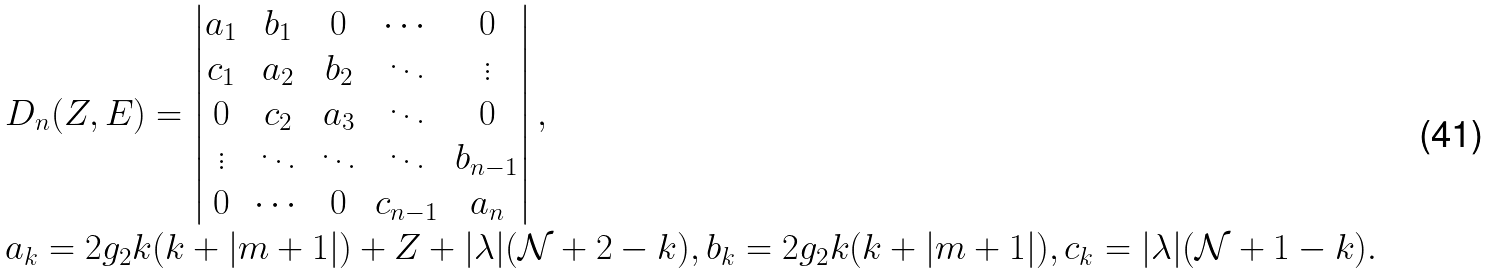Convert formula to latex. <formula><loc_0><loc_0><loc_500><loc_500>\begin{array} { l } D _ { n } ( Z , E ) = \left | \begin{matrix} a _ { 1 } & b _ { 1 } & 0 & \cdots & 0 \\ c _ { 1 } & a _ { 2 } & b _ { 2 } & \ddots & \vdots \\ 0 & c _ { 2 } & a _ { 3 } & \ddots & 0 \\ \vdots & \ddots & \ddots & \ddots & b _ { n - 1 } \\ 0 & \cdots & 0 & c _ { n - 1 } & a _ { n } \end{matrix} \right | , \\ a _ { k } = 2 g _ { 2 } k ( k + | m + 1 | ) + Z + | \lambda | ( \mathcal { N } + 2 - k ) , b _ { k } = 2 g _ { 2 } k ( k + | m + 1 | ) , c _ { k } = | \lambda | ( \mathcal { N } + 1 - k ) . \end{array}</formula> 